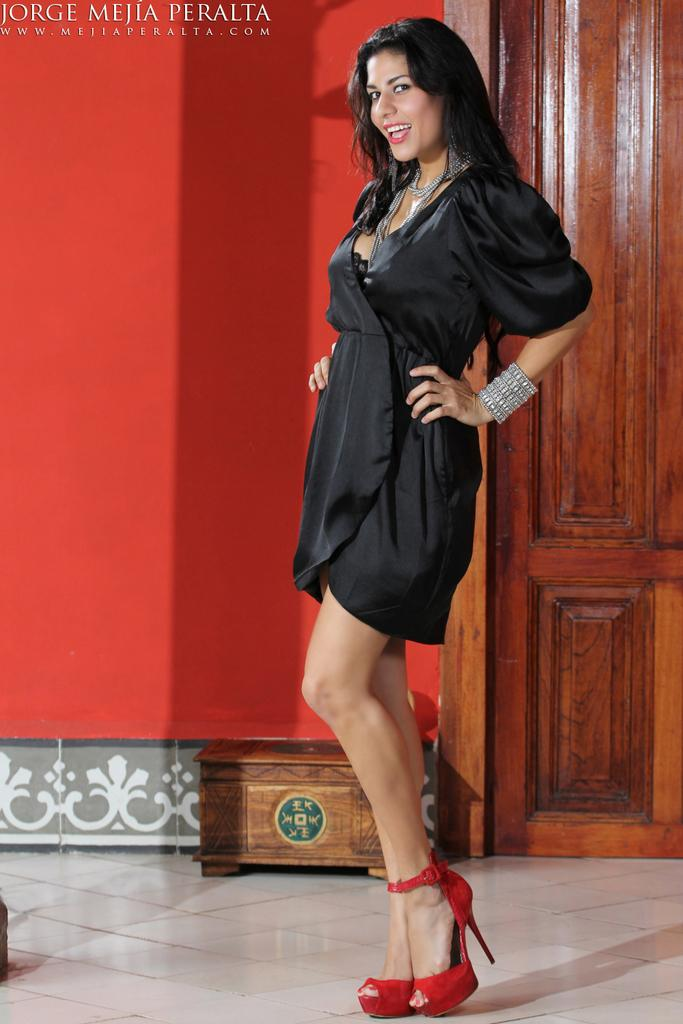What is the woman in the image doing? The woman is standing in the image and smiling. Can you describe any objects in the image? Yes, there is a wooden object and a door in the image. What is visible in the background of the image? There is a wall in the background of the image. Is there any indication of a watermark in the image? Yes, there is a watermark on the image. What type of pancake is being served by the band in the image? There is no pancake or band present in the image. How many pies can be seen on the wall in the image? There are no pies visible in the image; only a door and a wall are present. 